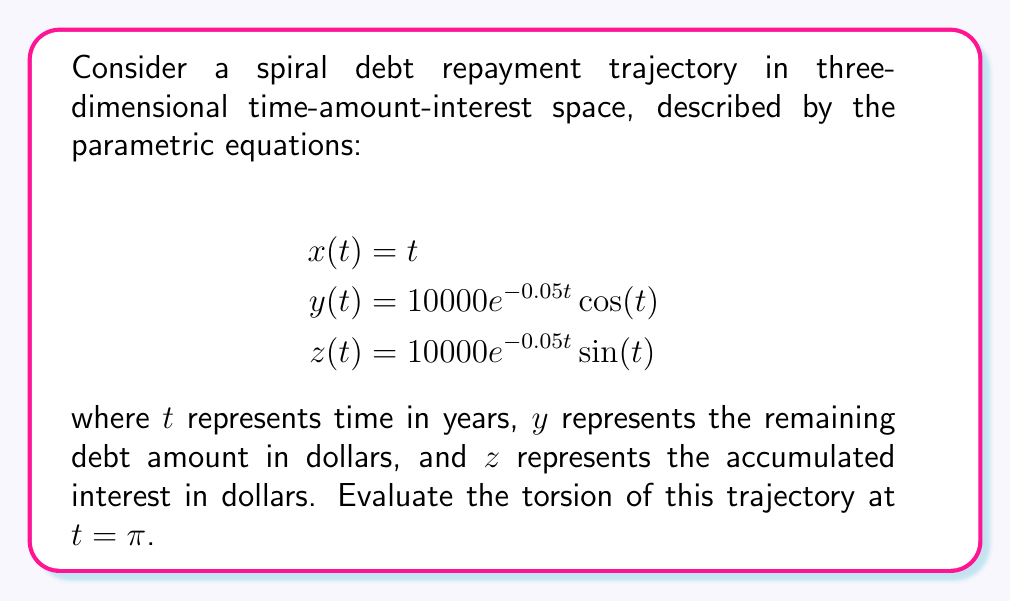Can you solve this math problem? To evaluate the torsion of the spiral debt repayment trajectory, we'll follow these steps:

1) First, we need to calculate the first, second, and third derivatives of the parametric equations:

   $$\mathbf{r}(t) = (t, 10000e^{-0.05t}\cos(t), 10000e^{-0.05t}\sin(t))$$

   $$\mathbf{r}'(t) = (1, -500e^{-0.05t}(\cos(t)+20\sin(t)), -500e^{-0.05t}(\sin(t)-20\cos(t)))$$

   $$\mathbf{r}''(t) = (0, 25e^{-0.05t}(40\cos(t)+39\sin(t)), 25e^{-0.05t}(40\sin(t)-39\cos(t)))$$

   $$\mathbf{r}'''(t) = (0, -1.25e^{-0.05t}(780\cos(t)+779\sin(t)), -1.25e^{-0.05t}(780\sin(t)-779\cos(t)))$$

2) The torsion is given by the formula:

   $$\tau = \frac{(\mathbf{r}' \times \mathbf{r}'') \cdot \mathbf{r}'''}{|\mathbf{r}' \times \mathbf{r}''|^2}$$

3) Let's evaluate each component at $t = \pi$:

   $$\mathbf{r}'(\pi) = (1, 500e^{-0.05\pi}, 0)$$
   $$\mathbf{r}''(\pi) = (0, -975e^{-0.05\pi}, 1000e^{-0.05\pi})$$
   $$\mathbf{r}'''(\pi) = (0, 973.75e^{-0.05\pi}, 975e^{-0.05\pi})$$

4) Now, let's calculate $\mathbf{r}' \times \mathbf{r}''$:

   $$\mathbf{r}' \times \mathbf{r}'' = (500000e^{-0.1\pi}, -1000e^{-0.05\pi}, 975e^{-0.05\pi})$$

5) Next, we calculate $(\mathbf{r}' \times \mathbf{r}'') \cdot \mathbf{r}'''$:

   $$(\mathbf{r}' \times \mathbf{r}'') \cdot \mathbf{r}''' = 486875e^{-0.15\pi} + 973750e^{-0.15\pi} = 1460625e^{-0.15\pi}$$

6) We also need $|\mathbf{r}' \times \mathbf{r}''|^2$:

   $$|\mathbf{r}' \times \mathbf{r}''|^2 = 250000000e^{-0.2\pi} + 1000000e^{-0.1\pi} + 950625e^{-0.1\pi}$$

7) Finally, we can calculate the torsion:

   $$\tau = \frac{1460625e^{-0.15\pi}}{250000000e^{-0.2\pi} + 1000000e^{-0.1\pi} + 950625e^{-0.1\pi}}$$

   $$\tau = \frac{1460625e^{0.05\pi}}{250000000 + 1000000e^{0.1\pi} + 950625e^{0.1\pi}}$$

   $$\tau \approx 0.0058$$
Answer: $0.0058$ 